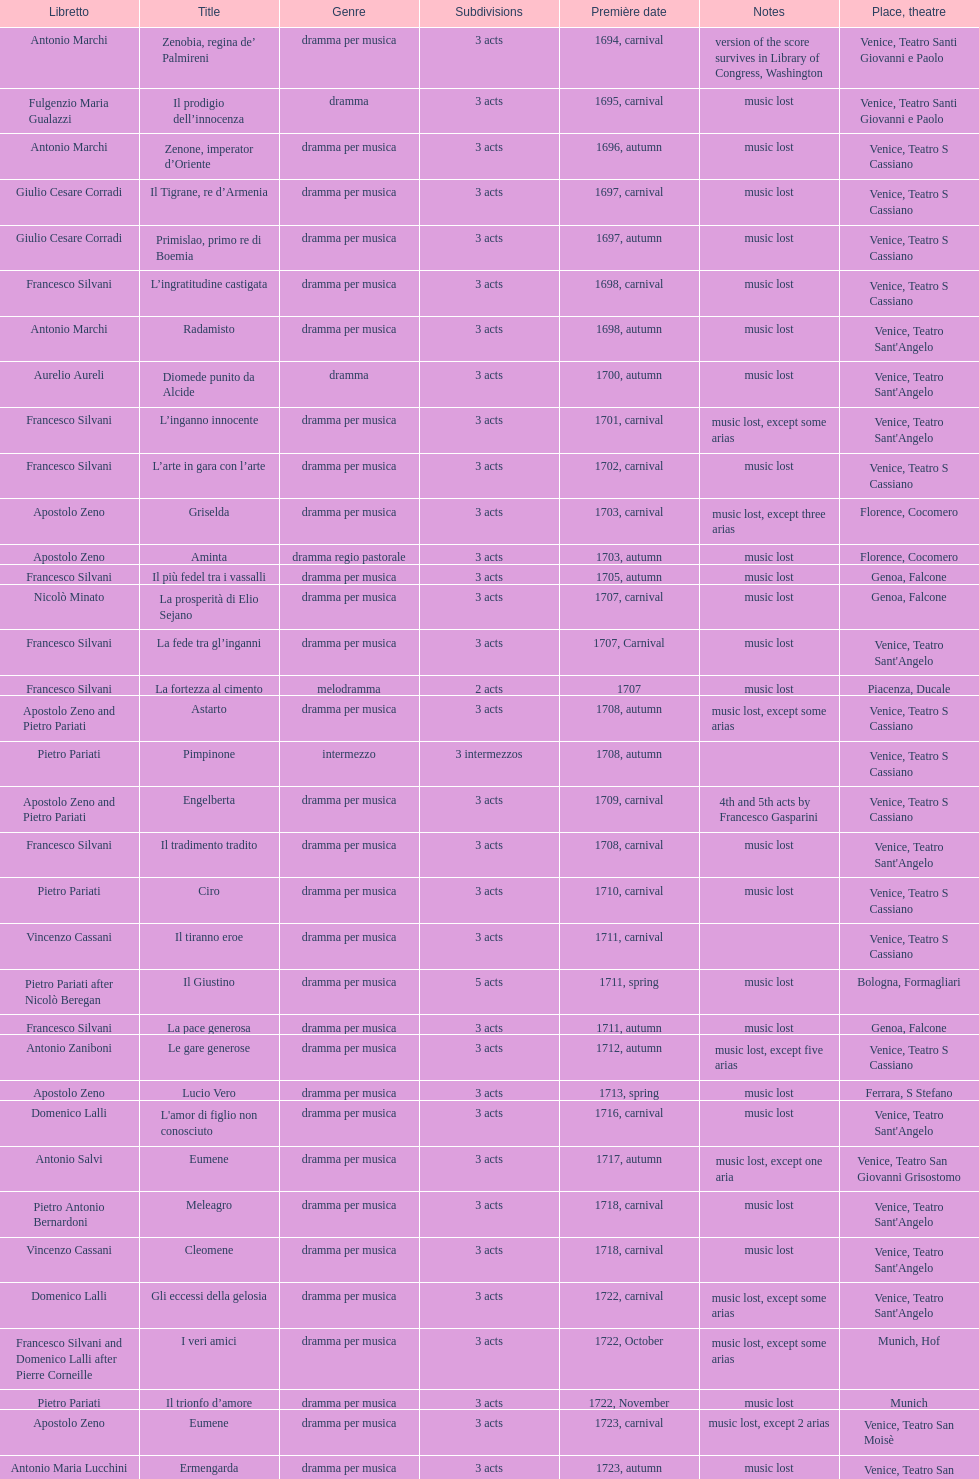Help me parse the entirety of this table. {'header': ['Libretto', 'Title', 'Genre', 'Sub\xaddivisions', 'Première date', 'Notes', 'Place, theatre'], 'rows': [['Antonio Marchi', 'Zenobia, regina de’ Palmireni', 'dramma per musica', '3 acts', '1694, carnival', 'version of the score survives in Library of Congress, Washington', 'Venice, Teatro Santi Giovanni e Paolo'], ['Fulgenzio Maria Gualazzi', 'Il prodigio dell’innocenza', 'dramma', '3 acts', '1695, carnival', 'music lost', 'Venice, Teatro Santi Giovanni e Paolo'], ['Antonio Marchi', 'Zenone, imperator d’Oriente', 'dramma per musica', '3 acts', '1696, autumn', 'music lost', 'Venice, Teatro S Cassiano'], ['Giulio Cesare Corradi', 'Il Tigrane, re d’Armenia', 'dramma per musica', '3 acts', '1697, carnival', 'music lost', 'Venice, Teatro S Cassiano'], ['Giulio Cesare Corradi', 'Primislao, primo re di Boemia', 'dramma per musica', '3 acts', '1697, autumn', 'music lost', 'Venice, Teatro S Cassiano'], ['Francesco Silvani', 'L’ingratitudine castigata', 'dramma per musica', '3 acts', '1698, carnival', 'music lost', 'Venice, Teatro S Cassiano'], ['Antonio Marchi', 'Radamisto', 'dramma per musica', '3 acts', '1698, autumn', 'music lost', "Venice, Teatro Sant'Angelo"], ['Aurelio Aureli', 'Diomede punito da Alcide', 'dramma', '3 acts', '1700, autumn', 'music lost', "Venice, Teatro Sant'Angelo"], ['Francesco Silvani', 'L’inganno innocente', 'dramma per musica', '3 acts', '1701, carnival', 'music lost, except some arias', "Venice, Teatro Sant'Angelo"], ['Francesco Silvani', 'L’arte in gara con l’arte', 'dramma per musica', '3 acts', '1702, carnival', 'music lost', 'Venice, Teatro S Cassiano'], ['Apostolo Zeno', 'Griselda', 'dramma per musica', '3 acts', '1703, carnival', 'music lost, except three arias', 'Florence, Cocomero'], ['Apostolo Zeno', 'Aminta', 'dramma regio pastorale', '3 acts', '1703, autumn', 'music lost', 'Florence, Cocomero'], ['Francesco Silvani', 'Il più fedel tra i vassalli', 'dramma per musica', '3 acts', '1705, autumn', 'music lost', 'Genoa, Falcone'], ['Nicolò Minato', 'La prosperità di Elio Sejano', 'dramma per musica', '3 acts', '1707, carnival', 'music lost', 'Genoa, Falcone'], ['Francesco Silvani', 'La fede tra gl’inganni', 'dramma per musica', '3 acts', '1707, Carnival', 'music lost', "Venice, Teatro Sant'Angelo"], ['Francesco Silvani', 'La fortezza al cimento', 'melodramma', '2 acts', '1707', 'music lost', 'Piacenza, Ducale'], ['Apostolo Zeno and Pietro Pariati', 'Astarto', 'dramma per musica', '3 acts', '1708, autumn', 'music lost, except some arias', 'Venice, Teatro S Cassiano'], ['Pietro Pariati', 'Pimpinone', 'intermezzo', '3 intermezzos', '1708, autumn', '', 'Venice, Teatro S Cassiano'], ['Apostolo Zeno and Pietro Pariati', 'Engelberta', 'dramma per musica', '3 acts', '1709, carnival', '4th and 5th acts by Francesco Gasparini', 'Venice, Teatro S Cassiano'], ['Francesco Silvani', 'Il tradimento tradito', 'dramma per musica', '3 acts', '1708, carnival', 'music lost', "Venice, Teatro Sant'Angelo"], ['Pietro Pariati', 'Ciro', 'dramma per musica', '3 acts', '1710, carnival', 'music lost', 'Venice, Teatro S Cassiano'], ['Vincenzo Cassani', 'Il tiranno eroe', 'dramma per musica', '3 acts', '1711, carnival', '', 'Venice, Teatro S Cassiano'], ['Pietro Pariati after Nicolò Beregan', 'Il Giustino', 'dramma per musica', '5 acts', '1711, spring', 'music lost', 'Bologna, Formagliari'], ['Francesco Silvani', 'La pace generosa', 'dramma per musica', '3 acts', '1711, autumn', 'music lost', 'Genoa, Falcone'], ['Antonio Zaniboni', 'Le gare generose', 'dramma per musica', '3 acts', '1712, autumn', 'music lost, except five arias', 'Venice, Teatro S Cassiano'], ['Apostolo Zeno', 'Lucio Vero', 'dramma per musica', '3 acts', '1713, spring', 'music lost', 'Ferrara, S Stefano'], ['Domenico Lalli', "L'amor di figlio non conosciuto", 'dramma per musica', '3 acts', '1716, carnival', 'music lost', "Venice, Teatro Sant'Angelo"], ['Antonio Salvi', 'Eumene', 'dramma per musica', '3 acts', '1717, autumn', 'music lost, except one aria', 'Venice, Teatro San Giovanni Grisostomo'], ['Pietro Antonio Bernardoni', 'Meleagro', 'dramma per musica', '3 acts', '1718, carnival', 'music lost', "Venice, Teatro Sant'Angelo"], ['Vincenzo Cassani', 'Cleomene', 'dramma per musica', '3 acts', '1718, carnival', 'music lost', "Venice, Teatro Sant'Angelo"], ['Domenico Lalli', 'Gli eccessi della gelosia', 'dramma per musica', '3 acts', '1722, carnival', 'music lost, except some arias', "Venice, Teatro Sant'Angelo"], ['Francesco Silvani and Domenico Lalli after Pierre Corneille', 'I veri amici', 'dramma per musica', '3 acts', '1722, October', 'music lost, except some arias', 'Munich, Hof'], ['Pietro Pariati', 'Il trionfo d’amore', 'dramma per musica', '3 acts', '1722, November', 'music lost', 'Munich'], ['Apostolo Zeno', 'Eumene', 'dramma per musica', '3 acts', '1723, carnival', 'music lost, except 2 arias', 'Venice, Teatro San Moisè'], ['Antonio Maria Lucchini', 'Ermengarda', 'dramma per musica', '3 acts', '1723, autumn', 'music lost', 'Venice, Teatro San Moisè'], ['Giovanni Piazzon', 'Antigono, tutore di Filippo, re di Macedonia', 'tragedia', '5 acts', '1724, carnival', '5th act by Giovanni Porta, music lost', 'Venice, Teatro San Moisè'], ['Apostolo Zeno', 'Scipione nelle Spagne', 'dramma per musica', '3 acts', '1724, Ascension', 'music lost', 'Venice, Teatro San Samuele'], ['Angelo Schietti', 'Laodice', 'dramma per musica', '3 acts', '1724, autumn', 'music lost, except 2 arias', 'Venice, Teatro San Moisè'], ['Metastasio', 'Didone abbandonata', 'tragedia', '3 acts', '1725, carnival', 'music lost', 'Venice, Teatro S Cassiano'], ['Metastasio', "L'impresario delle Isole Canarie", 'intermezzo', '2 acts', '1725, carnival', 'music lost', 'Venice, Teatro S Cassiano'], ['Antonio Marchi', 'Alcina delusa da Ruggero', 'dramma per musica', '3 acts', '1725, autumn', 'music lost', 'Venice, Teatro S Cassiano'], ['Apostolo Zeno', 'I rivali generosi', 'dramma per musica', '3 acts', '1725', '', 'Brescia, Nuovo'], ['Apostolo Zeno and Pietro Pariati', 'La Statira', 'dramma per musica', '3 acts', '1726, Carnival', '', 'Rome, Teatro Capranica'], ['', 'Malsazio e Fiammetta', 'intermezzo', '', '1726, Carnival', '', 'Rome, Teatro Capranica'], ['Girolamo Colatelli after Torquato Tasso', 'Il trionfo di Armida', 'dramma per musica', '3 acts', '1726, autumn', 'music lost', 'Venice, Teatro San Moisè'], ['Vincenzo Cassani', 'L’incostanza schernita', 'dramma comico-pastorale', '3 acts', '1727, Ascension', 'music lost, except some arias', 'Venice, Teatro San Samuele'], ['Aurelio Aureli', 'Le due rivali in amore', 'dramma per musica', '3 acts', '1728, autumn', 'music lost', 'Venice, Teatro San Moisè'], ['Salvi', 'Il Satrapone', 'intermezzo', '', '1729', '', 'Parma, Omodeo'], ['F Passerini', 'Li stratagemmi amorosi', 'dramma per musica', '3 acts', '1730, carnival', 'music lost', 'Venice, Teatro San Moisè'], ['Luisa Bergalli', 'Elenia', 'dramma per musica', '3 acts', '1730, carnival', 'music lost', "Venice, Teatro Sant'Angelo"], ['Apostolo Zeno', 'Merope', 'dramma', '3 acts', '1731, autumn', 'mostly by Albinoni, music lost', 'Prague, Sporck Theater'], ['Angelo Schietti', 'Il più infedel tra gli amanti', 'dramma per musica', '3 acts', '1731, autumn', 'music lost', 'Treviso, Dolphin'], ['Bartolomeo Vitturi', 'Ardelinda', 'dramma', '3 acts', '1732, autumn', 'music lost, except five arias', "Venice, Teatro Sant'Angelo"], ['Bartolomeo Vitturi', 'Candalide', 'dramma per musica', '3 acts', '1734, carnival', 'music lost', "Venice, Teatro Sant'Angelo"], ['Bartolomeo Vitturi', 'Artamene', 'dramma per musica', '3 acts', '1741, carnival', 'music lost', "Venice, Teatro Sant'Angelo"]]} Which opera has at least 5 acts? Il Giustino. 